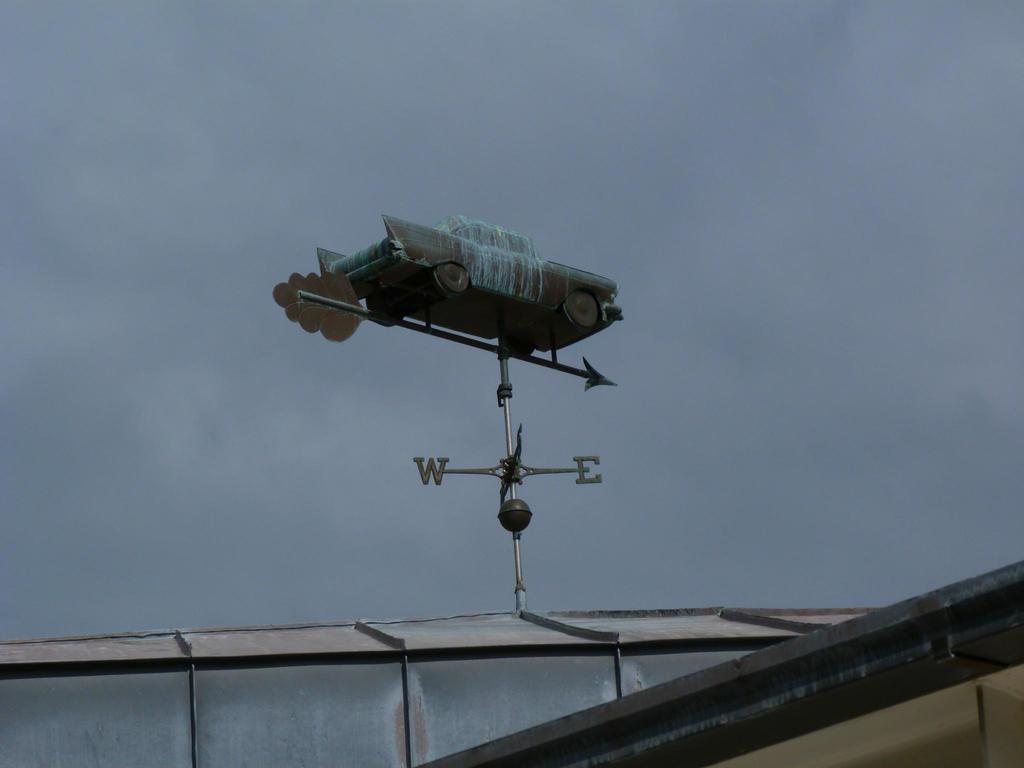What direction is the front of the car on the weather vane pointing?
Offer a very short reply. East. What world do the two letters spell in the image?
Ensure brevity in your answer.  We. 